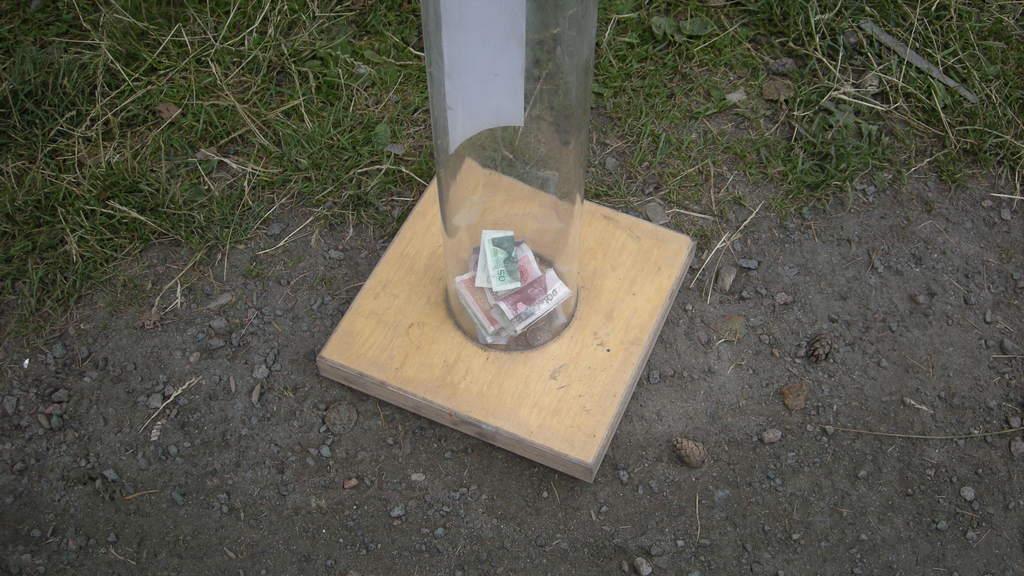Please provide a concise description of this image. We can see currency in a glass container and we can see grass. 